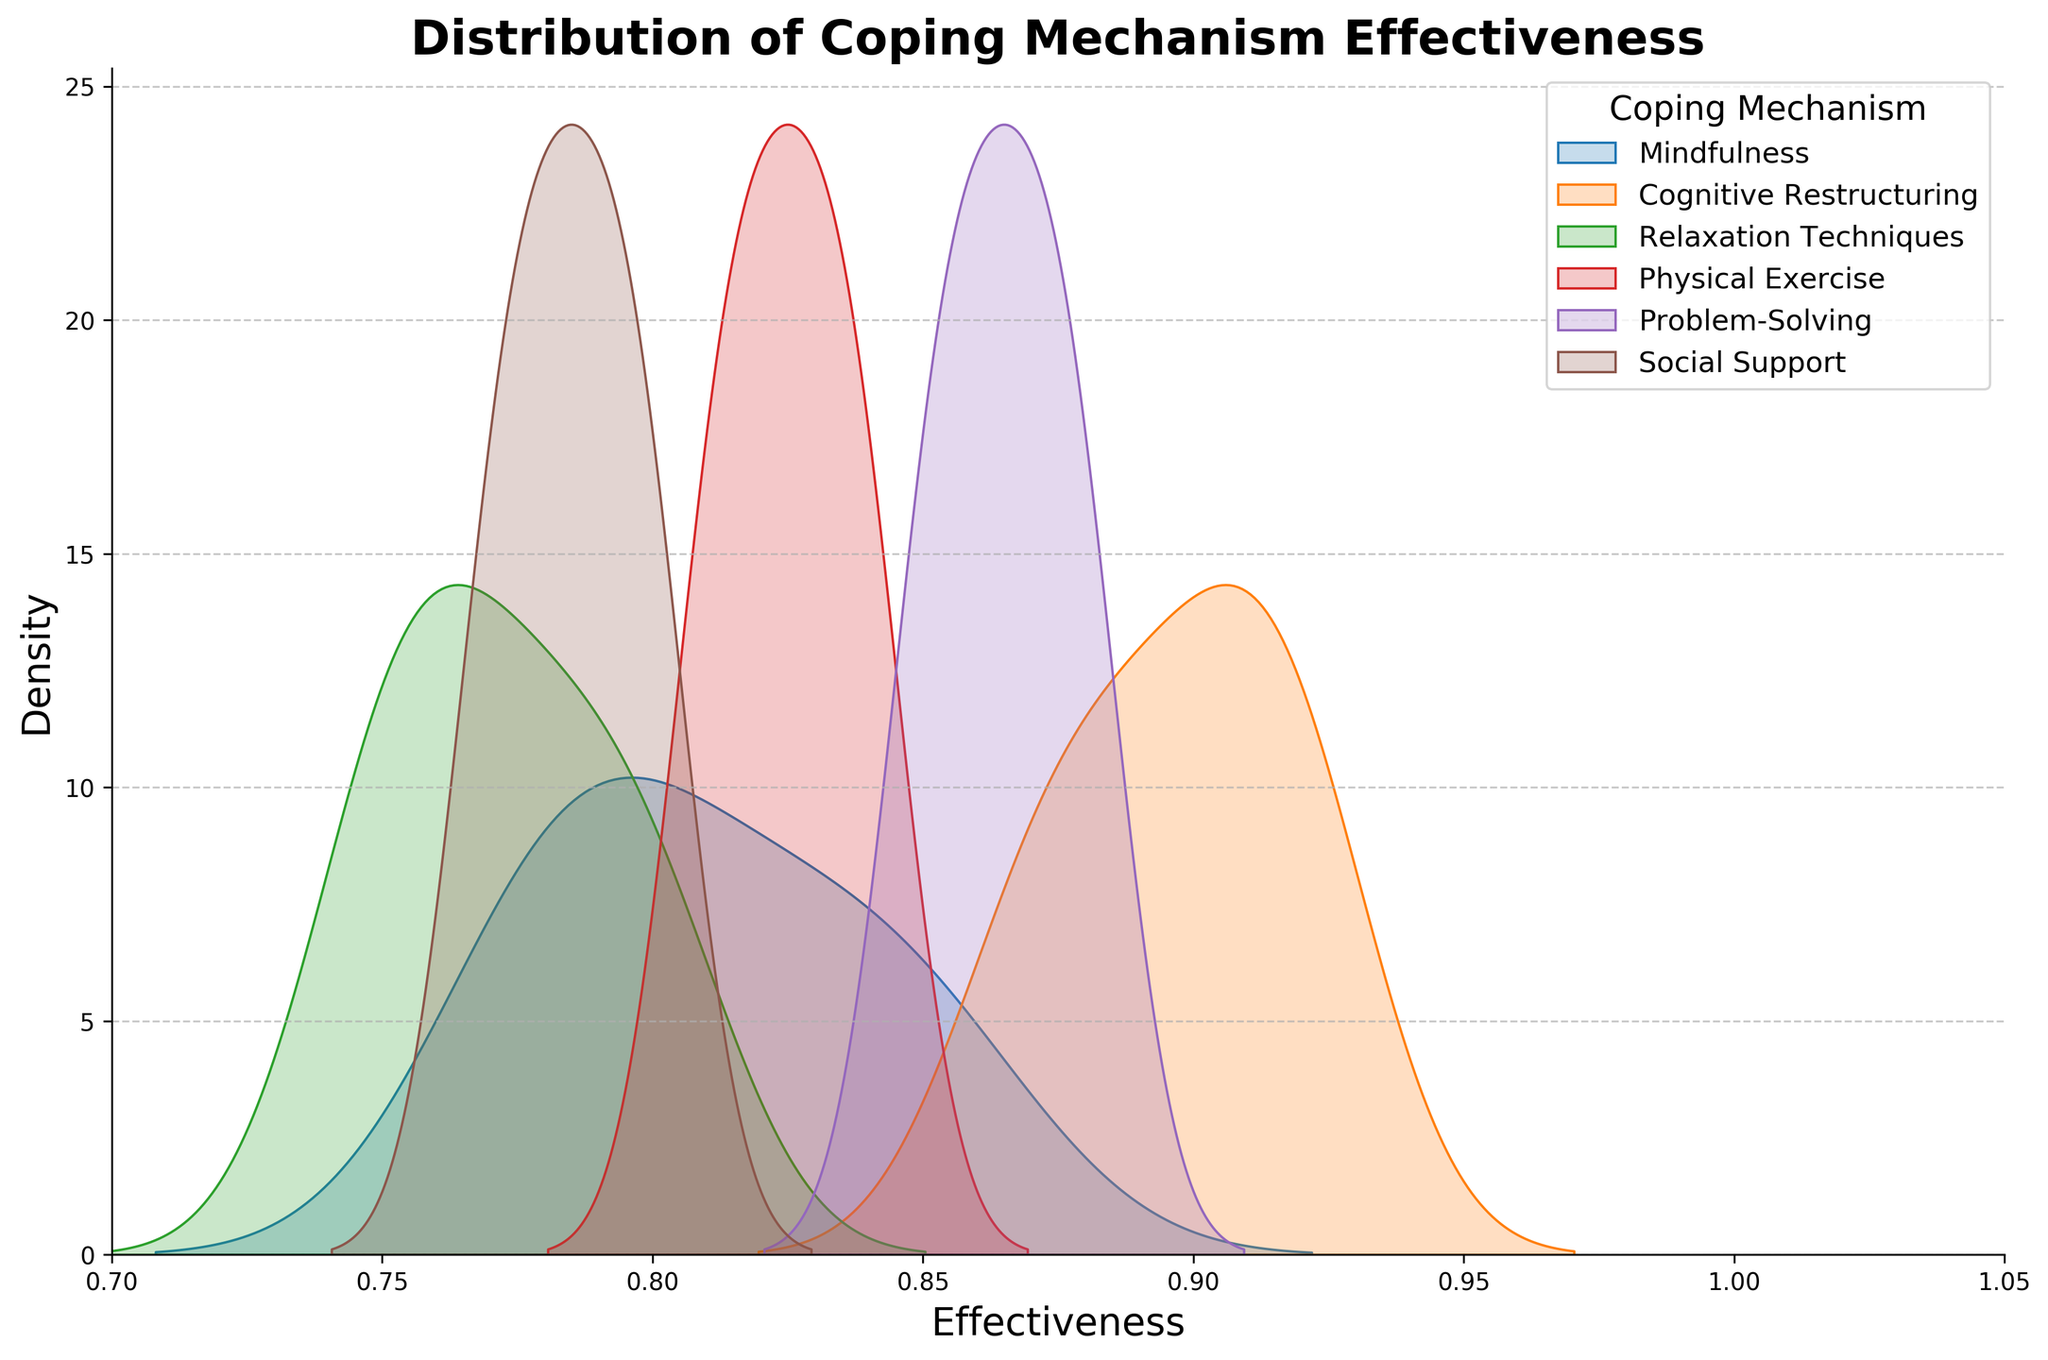What is the title of the figure? The title is usually displayed at the top of the figure. In this case, it is mentioned as part of the code to be 'Distribution of Coping Mechanism Effectiveness'.
Answer: Distribution of Coping Mechanism Effectiveness Which axis represents effectiveness? Axis labels help in identifying what each axis represents. According to the provided code, the x-axis label is 'Effectiveness'.
Answer: x-axis Over what range is the x-axis of the figure set? The x-axis limit is set in the code between 0.7 and 1.0.
Answer: 0.7 to 1.0 Which coping mechanism has the highest peak density in the figure? The peak density can be identified by looking at the maximum height of each curve in the plot. By looking at the KDE peaks, it can be determined.
Answer: Cognitive Restructuring How many coping mechanisms are plotted in the figure? Each unique coping mechanism generates a different curve as per the code which loops over unique values of 'coping_mechanism'. There are 6 mechanisms detailed in the data.
Answer: 6 Which coping mechanism's effectiveness has the broadest distribution? The broadest distribution would have the widest spread in the KDE plot. Observing the KDE plots, "Social Support" appears to have the broadest spread of effectiveness values from 0.77 to 0.80.
Answer: Social Support What is the median effectiveness for 'Mindfulness' compared to 'Problem-Solving'? The median can be approximately observed from the center point in each KDE plot for the specified coping mechanisms. From the KDE, 'Mindfulness' centers around 0.80 while 'Problem-Solving' centers around 0.86.
Answer: Mindfulness: ~0.80, Problem-Solving: ~0.86 Which two coping mechanisms appear to have overlapping distributions? Overlapping distributions appear as KDE plots whose curves intersect or are very close together. 'Social Support' and 'Relaxation Techniques' seem to have overlapping KDE plots around the values 0.78 to 0.80.
Answer: Social Support and Relaxation Techniques In terms of density, which coping mechanism's KDE plot tends to fall around 0.85? Density close to 0.85 is highlighted in KDE plots. 'Physical Exercise' and 'Mindfulness' KDE peaks are seen clustering around this value.
Answer: Physical Exercise and Mindfulness 